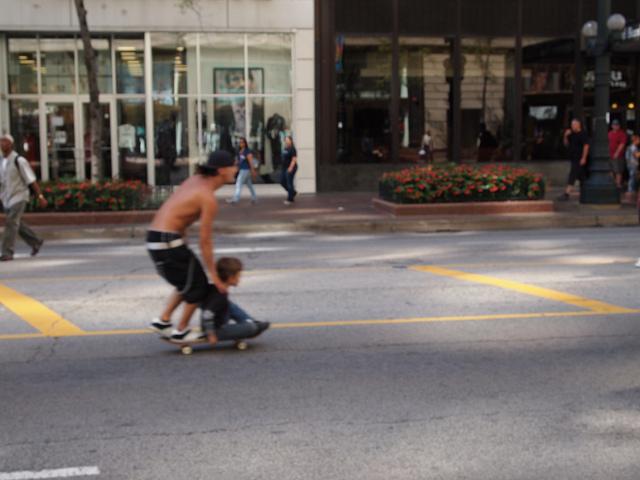Is the man wearing a hat?
Answer briefly. Yes. How many headlights are visible?
Write a very short answer. 0. What vehicle is being used?
Give a very brief answer. Skateboard. Is there an animal in the image?
Quick response, please. No. What does the window on the right say?
Quick response, please. Nothing. What is displayed on the sidewalk?
Give a very brief answer. Flowers. Is everyone wearing a shirt?
Give a very brief answer. No. How many skateboarders are not wearing safety equipment?
Be succinct. 2. Why is are the people on the skateboard in danger?
Write a very short answer. In street. What is on the outside of the windows and doors?
Answer briefly. Flower garden. How many boards are shown?
Write a very short answer. 1. What is the person riding?
Be succinct. Skateboard. What is her color?
Be succinct. White. 